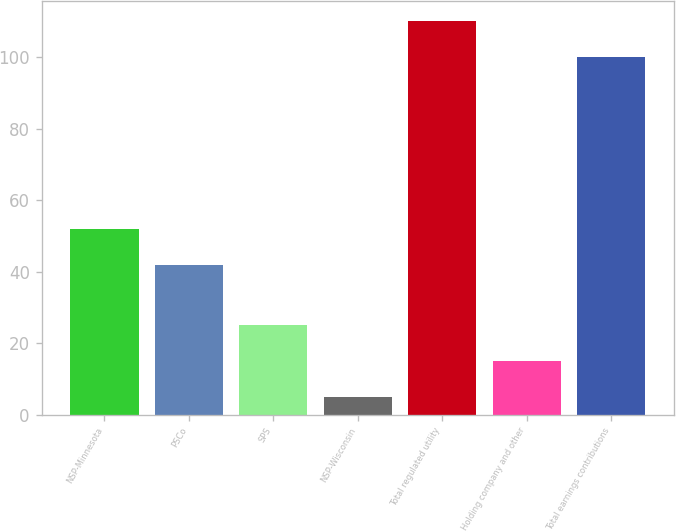Convert chart to OTSL. <chart><loc_0><loc_0><loc_500><loc_500><bar_chart><fcel>NSP-Minnesota<fcel>PSCo<fcel>SPS<fcel>NSP-Wisconsin<fcel>Total regulated utility<fcel>Holding company and other<fcel>Total earnings contributions<nl><fcel>51.78<fcel>41.7<fcel>25.16<fcel>5<fcel>110.08<fcel>15.08<fcel>100<nl></chart> 